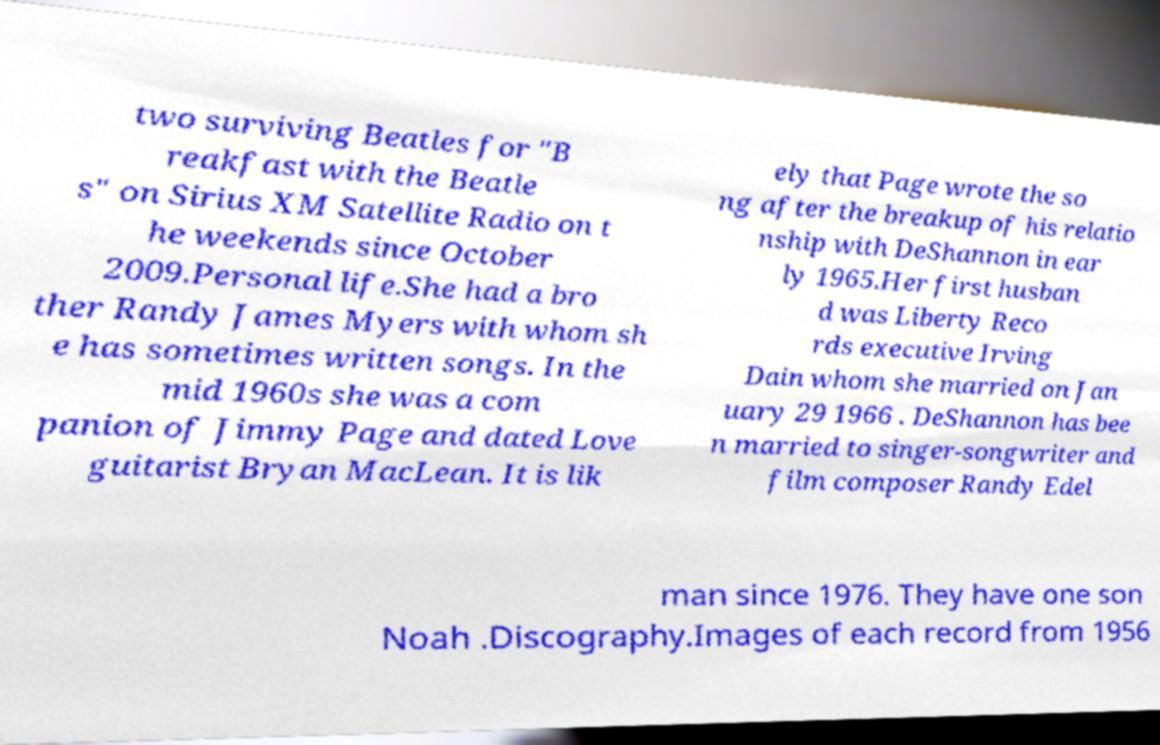Could you assist in decoding the text presented in this image and type it out clearly? two surviving Beatles for "B reakfast with the Beatle s" on Sirius XM Satellite Radio on t he weekends since October 2009.Personal life.She had a bro ther Randy James Myers with whom sh e has sometimes written songs. In the mid 1960s she was a com panion of Jimmy Page and dated Love guitarist Bryan MacLean. It is lik ely that Page wrote the so ng after the breakup of his relatio nship with DeShannon in ear ly 1965.Her first husban d was Liberty Reco rds executive Irving Dain whom she married on Jan uary 29 1966 . DeShannon has bee n married to singer-songwriter and film composer Randy Edel man since 1976. They have one son Noah .Discography.Images of each record from 1956 